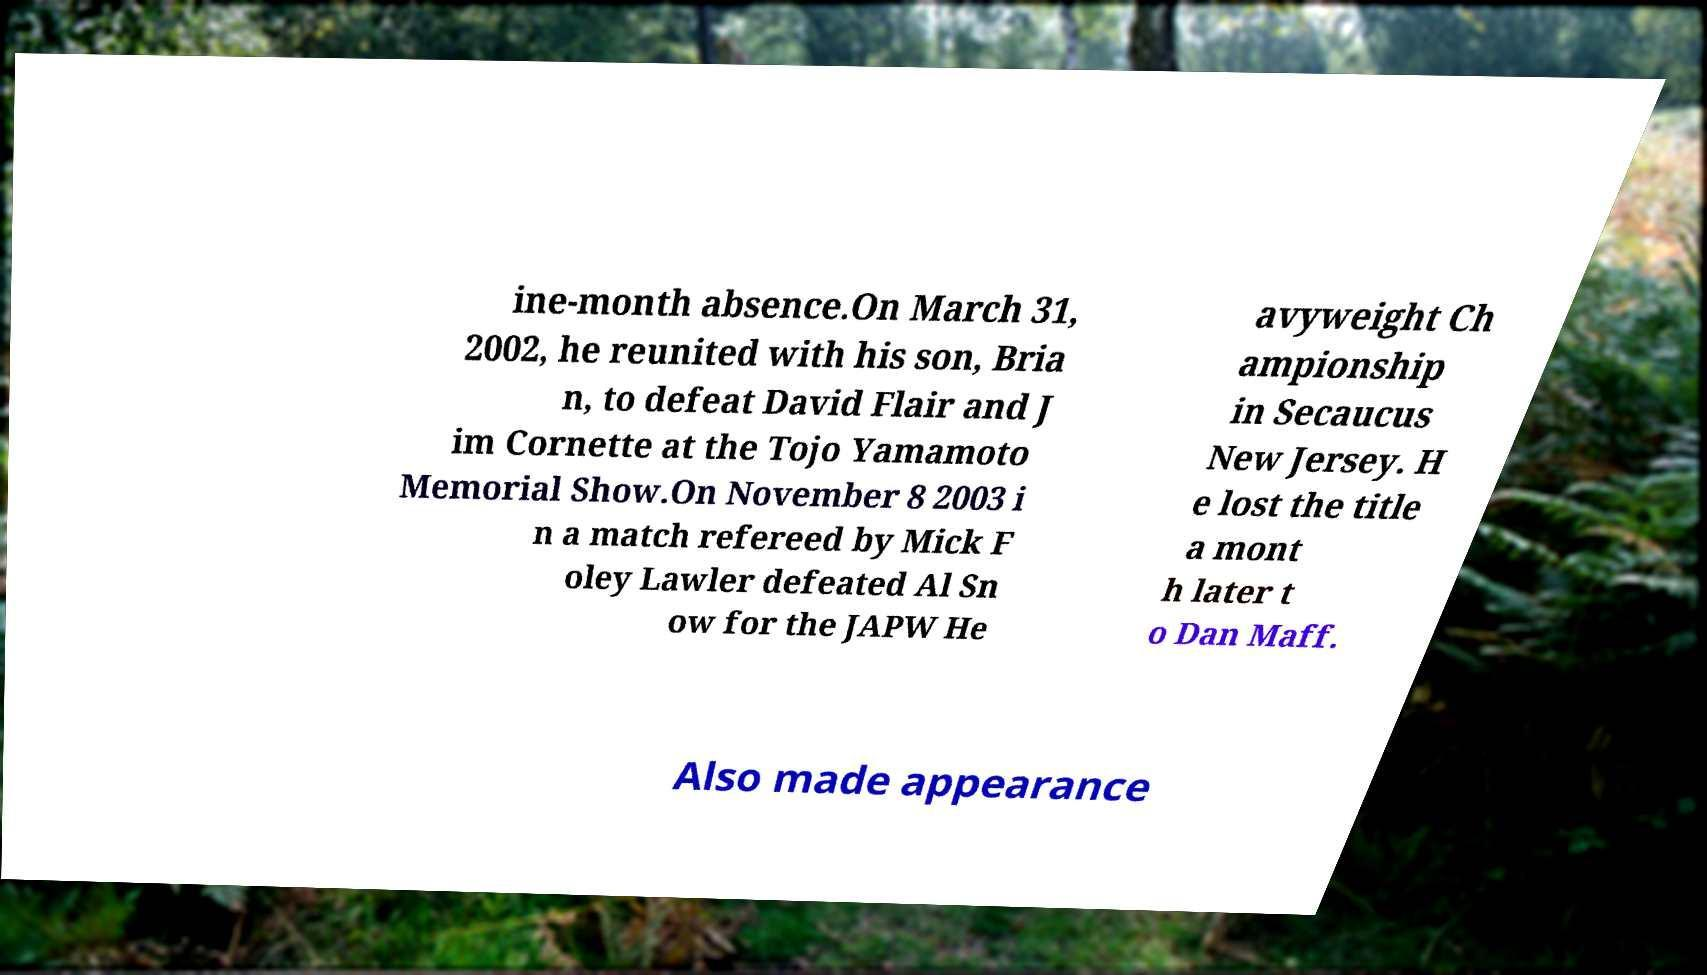Can you read and provide the text displayed in the image?This photo seems to have some interesting text. Can you extract and type it out for me? ine-month absence.On March 31, 2002, he reunited with his son, Bria n, to defeat David Flair and J im Cornette at the Tojo Yamamoto Memorial Show.On November 8 2003 i n a match refereed by Mick F oley Lawler defeated Al Sn ow for the JAPW He avyweight Ch ampionship in Secaucus New Jersey. H e lost the title a mont h later t o Dan Maff. Also made appearance 